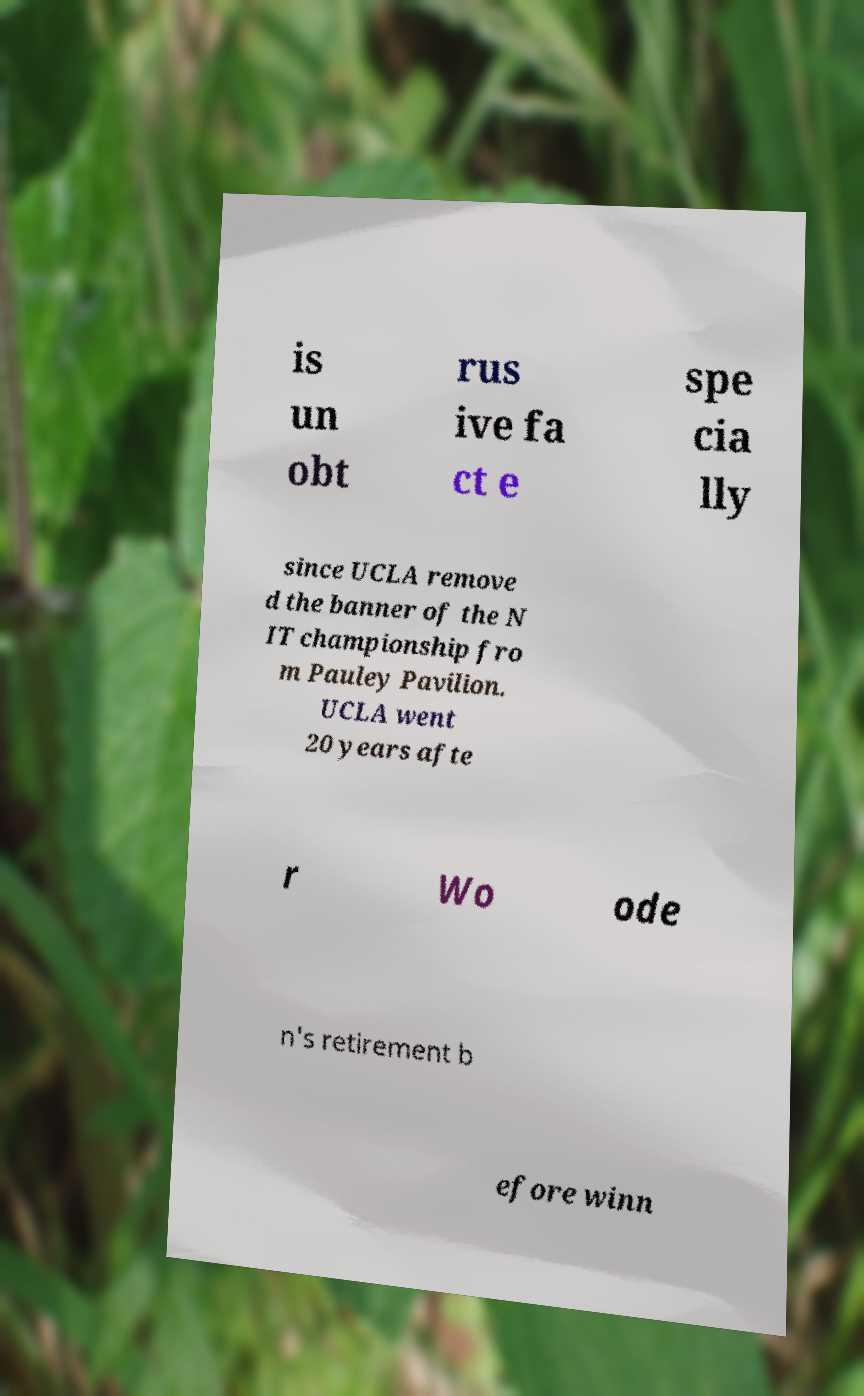Can you read and provide the text displayed in the image?This photo seems to have some interesting text. Can you extract and type it out for me? is un obt rus ive fa ct e spe cia lly since UCLA remove d the banner of the N IT championship fro m Pauley Pavilion. UCLA went 20 years afte r Wo ode n's retirement b efore winn 